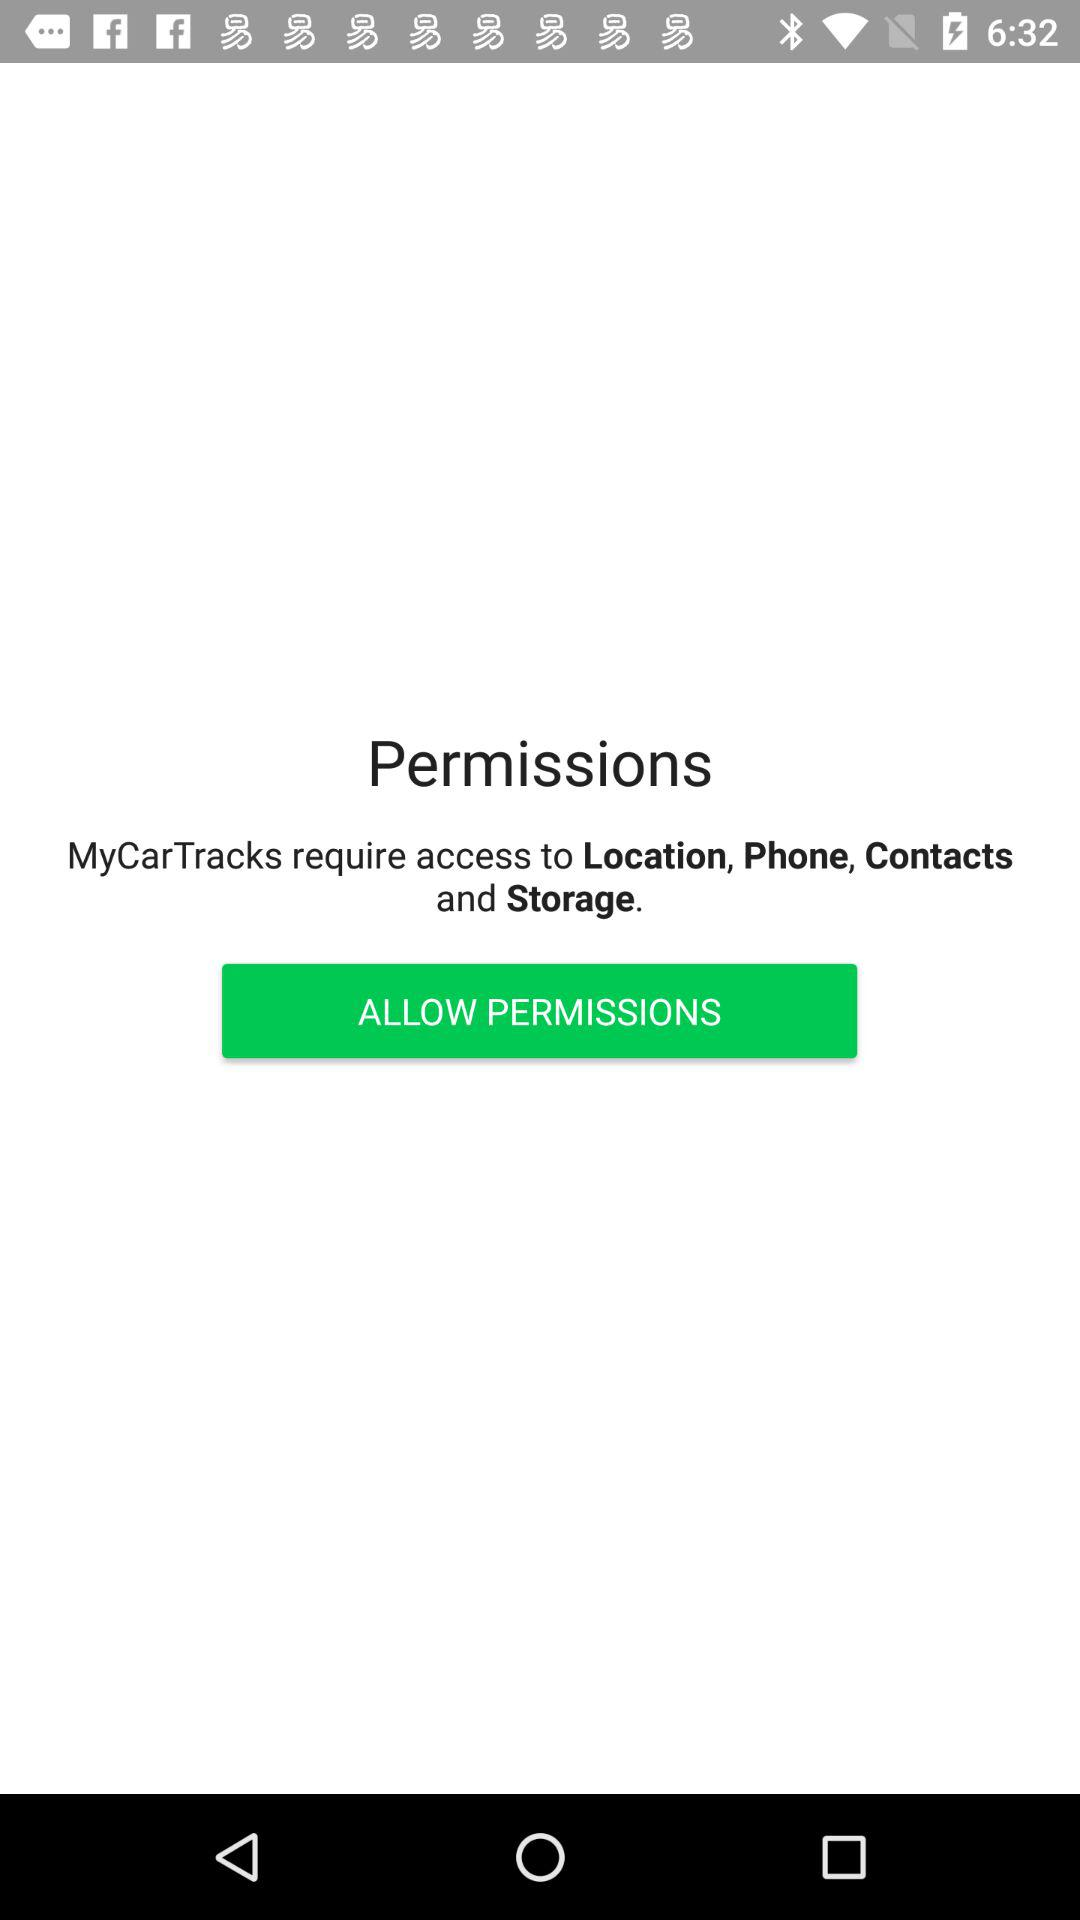How many more permissions does MyCarTracks require than Location?
Answer the question using a single word or phrase. 3 